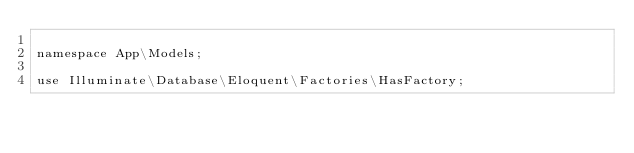Convert code to text. <code><loc_0><loc_0><loc_500><loc_500><_PHP_>
namespace App\Models;

use Illuminate\Database\Eloquent\Factories\HasFactory;</code> 